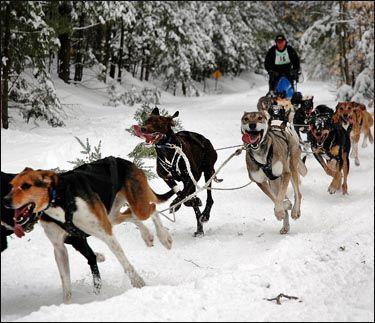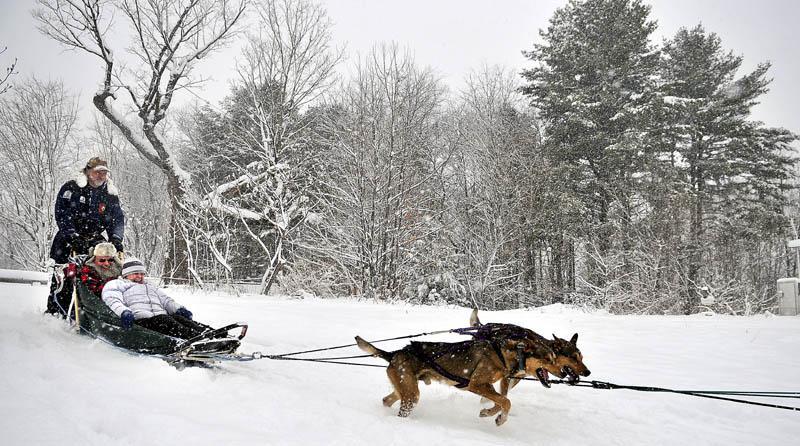The first image is the image on the left, the second image is the image on the right. Evaluate the accuracy of this statement regarding the images: "There are at least two people sitting down riding a sled.". Is it true? Answer yes or no. Yes. The first image is the image on the left, the second image is the image on the right. Evaluate the accuracy of this statement regarding the images: "Two light colored dogs are pulling a sled in one of the images.". Is it true? Answer yes or no. No. 